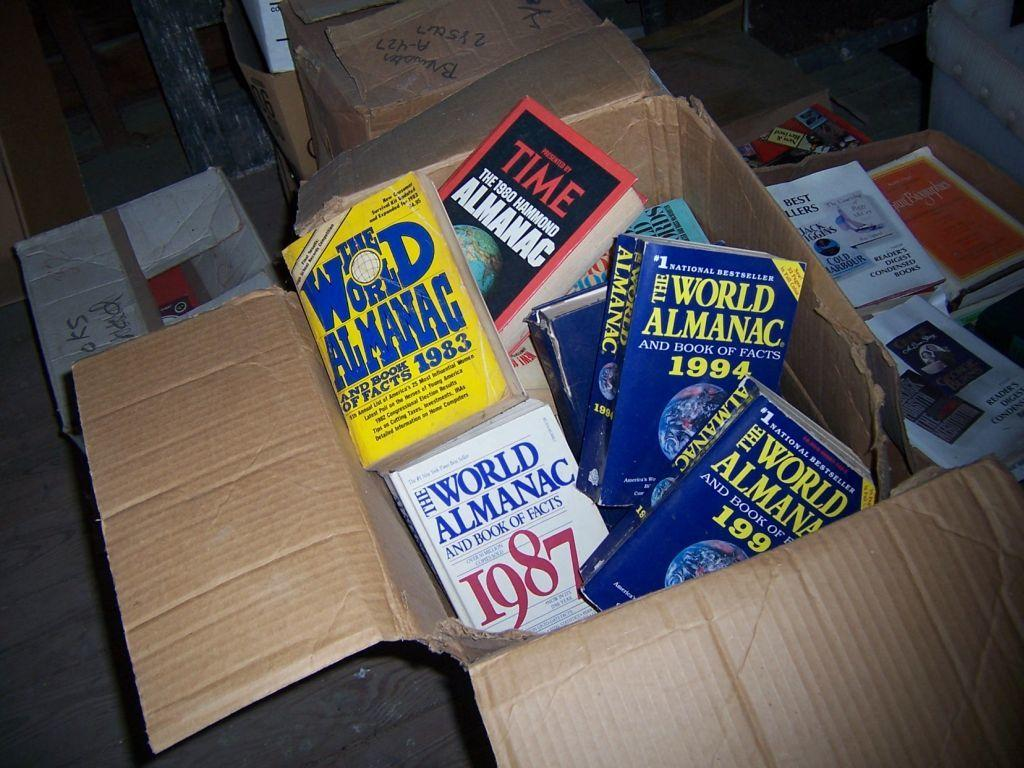Provide a one-sentence caption for the provided image. World amanac books inside of a cardboard box. 